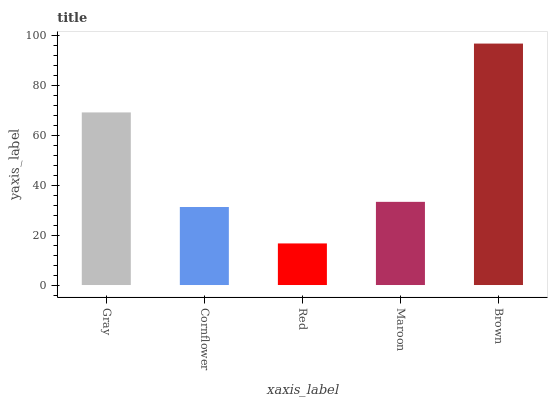Is Red the minimum?
Answer yes or no. Yes. Is Brown the maximum?
Answer yes or no. Yes. Is Cornflower the minimum?
Answer yes or no. No. Is Cornflower the maximum?
Answer yes or no. No. Is Gray greater than Cornflower?
Answer yes or no. Yes. Is Cornflower less than Gray?
Answer yes or no. Yes. Is Cornflower greater than Gray?
Answer yes or no. No. Is Gray less than Cornflower?
Answer yes or no. No. Is Maroon the high median?
Answer yes or no. Yes. Is Maroon the low median?
Answer yes or no. Yes. Is Red the high median?
Answer yes or no. No. Is Brown the low median?
Answer yes or no. No. 